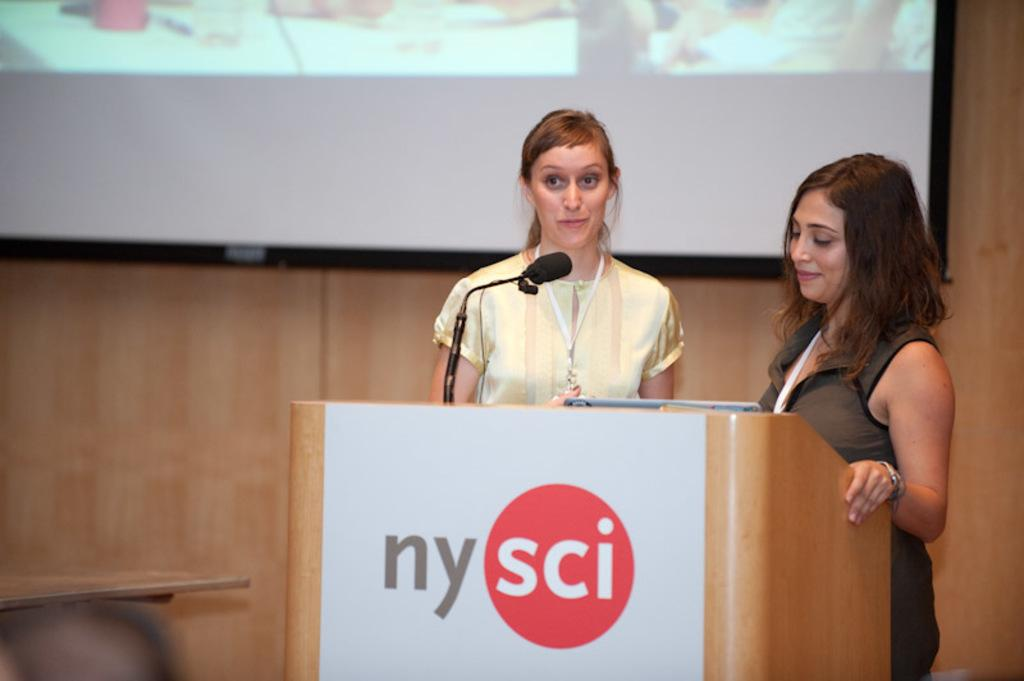What is happening in the image? There are persons in front of a podium in the image. Can you describe any other objects or features in the image? Yes, there is a screen at the top of the image. What type of wheel is visible on the podium in the image? There is no wheel visible on the podium in the image. Is there any water visible in the image? No, there is no water visible in the image. Can you see any cooking utensils or ingredients in the image? No, there are no cooking utensils or ingredients visible in the image. 